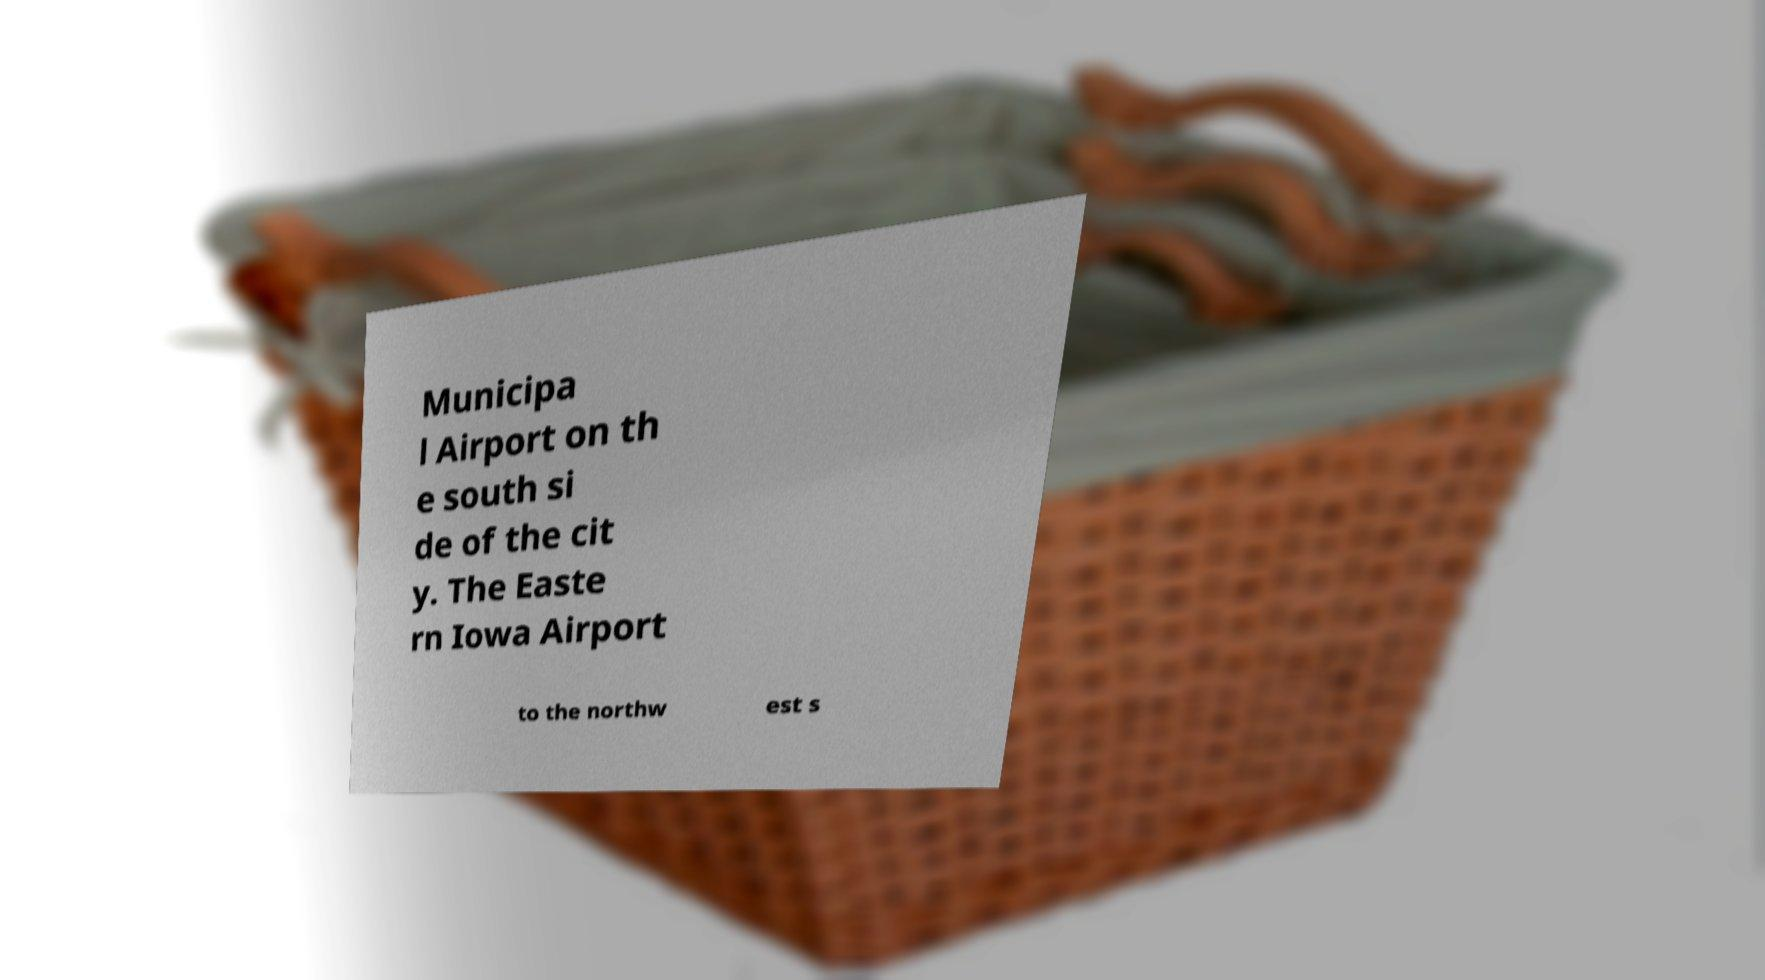Please read and relay the text visible in this image. What does it say? Municipa l Airport on th e south si de of the cit y. The Easte rn Iowa Airport to the northw est s 